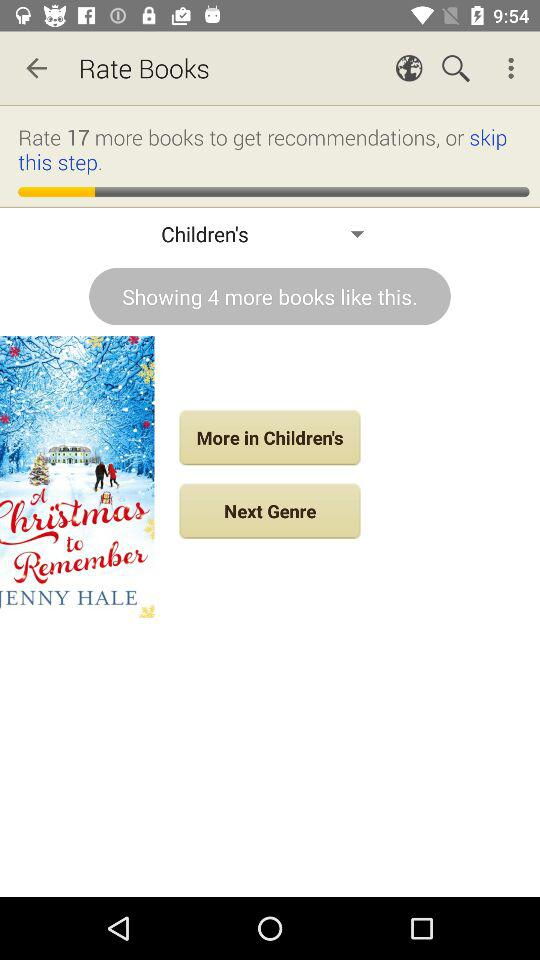How many more books like this are there?
Answer the question using a single word or phrase. 4 